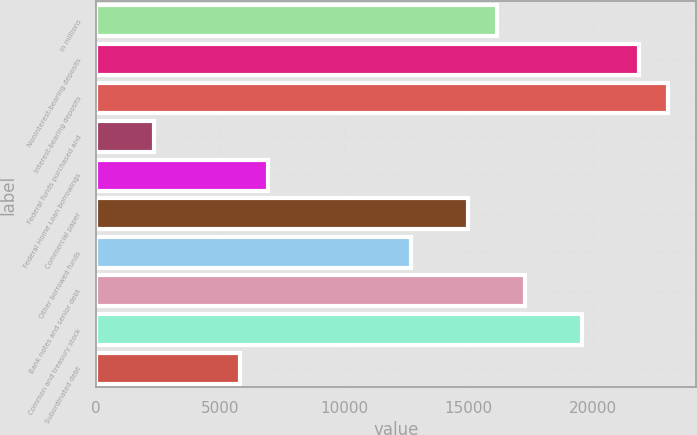Convert chart to OTSL. <chart><loc_0><loc_0><loc_500><loc_500><bar_chart><fcel>In millions<fcel>Noninterest-bearing deposits<fcel>Interest-bearing deposits<fcel>Federal funds purchased and<fcel>Federal Home Loan borrowings<fcel>Commercial paper<fcel>Other borrowed funds<fcel>Bank notes and senior debt<fcel>Common and treasury stock<fcel>Subordinated debt<nl><fcel>16123.2<fcel>21862.2<fcel>23010<fcel>2349.6<fcel>6940.8<fcel>14975.4<fcel>12679.8<fcel>17271<fcel>19566.6<fcel>5793<nl></chart> 